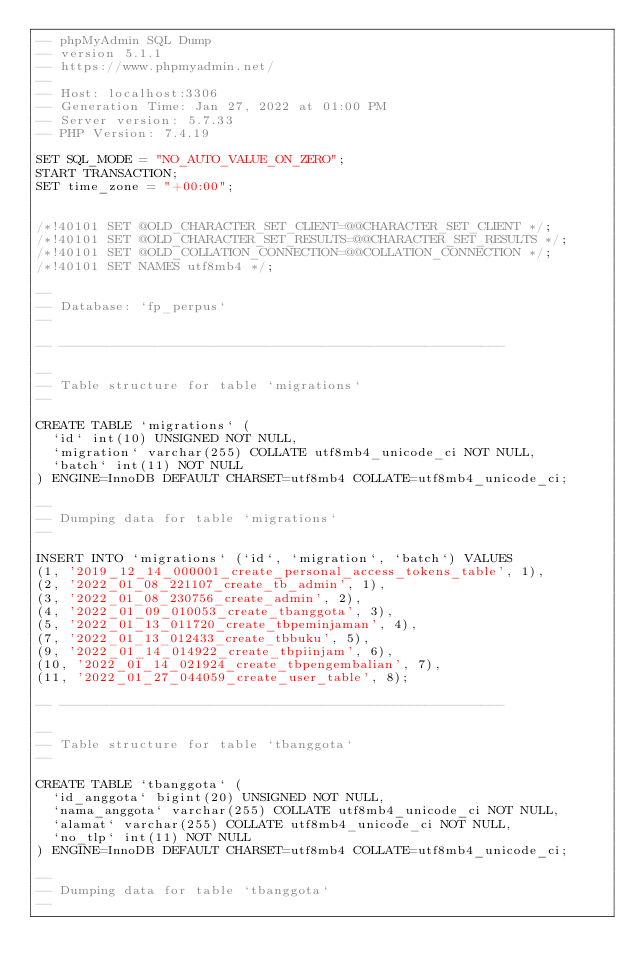Convert code to text. <code><loc_0><loc_0><loc_500><loc_500><_SQL_>-- phpMyAdmin SQL Dump
-- version 5.1.1
-- https://www.phpmyadmin.net/
--
-- Host: localhost:3306
-- Generation Time: Jan 27, 2022 at 01:00 PM
-- Server version: 5.7.33
-- PHP Version: 7.4.19

SET SQL_MODE = "NO_AUTO_VALUE_ON_ZERO";
START TRANSACTION;
SET time_zone = "+00:00";


/*!40101 SET @OLD_CHARACTER_SET_CLIENT=@@CHARACTER_SET_CLIENT */;
/*!40101 SET @OLD_CHARACTER_SET_RESULTS=@@CHARACTER_SET_RESULTS */;
/*!40101 SET @OLD_COLLATION_CONNECTION=@@COLLATION_CONNECTION */;
/*!40101 SET NAMES utf8mb4 */;

--
-- Database: `fp_perpus`
--

-- --------------------------------------------------------

--
-- Table structure for table `migrations`
--

CREATE TABLE `migrations` (
  `id` int(10) UNSIGNED NOT NULL,
  `migration` varchar(255) COLLATE utf8mb4_unicode_ci NOT NULL,
  `batch` int(11) NOT NULL
) ENGINE=InnoDB DEFAULT CHARSET=utf8mb4 COLLATE=utf8mb4_unicode_ci;

--
-- Dumping data for table `migrations`
--

INSERT INTO `migrations` (`id`, `migration`, `batch`) VALUES
(1, '2019_12_14_000001_create_personal_access_tokens_table', 1),
(2, '2022_01_08_221107_create_tb_admin', 1),
(3, '2022_01_08_230756_create_admin', 2),
(4, '2022_01_09_010053_create_tbanggota', 3),
(5, '2022_01_13_011720_create_tbpeminjaman', 4),
(7, '2022_01_13_012433_create_tbbuku', 5),
(9, '2022_01_14_014922_create_tbpiinjam', 6),
(10, '2022_01_14_021924_create_tbpengembalian', 7),
(11, '2022_01_27_044059_create_user_table', 8);

-- --------------------------------------------------------

--
-- Table structure for table `tbanggota`
--

CREATE TABLE `tbanggota` (
  `id_anggota` bigint(20) UNSIGNED NOT NULL,
  `nama_anggota` varchar(255) COLLATE utf8mb4_unicode_ci NOT NULL,
  `alamat` varchar(255) COLLATE utf8mb4_unicode_ci NOT NULL,
  `no_tlp` int(11) NOT NULL
) ENGINE=InnoDB DEFAULT CHARSET=utf8mb4 COLLATE=utf8mb4_unicode_ci;

--
-- Dumping data for table `tbanggota`
--
</code> 